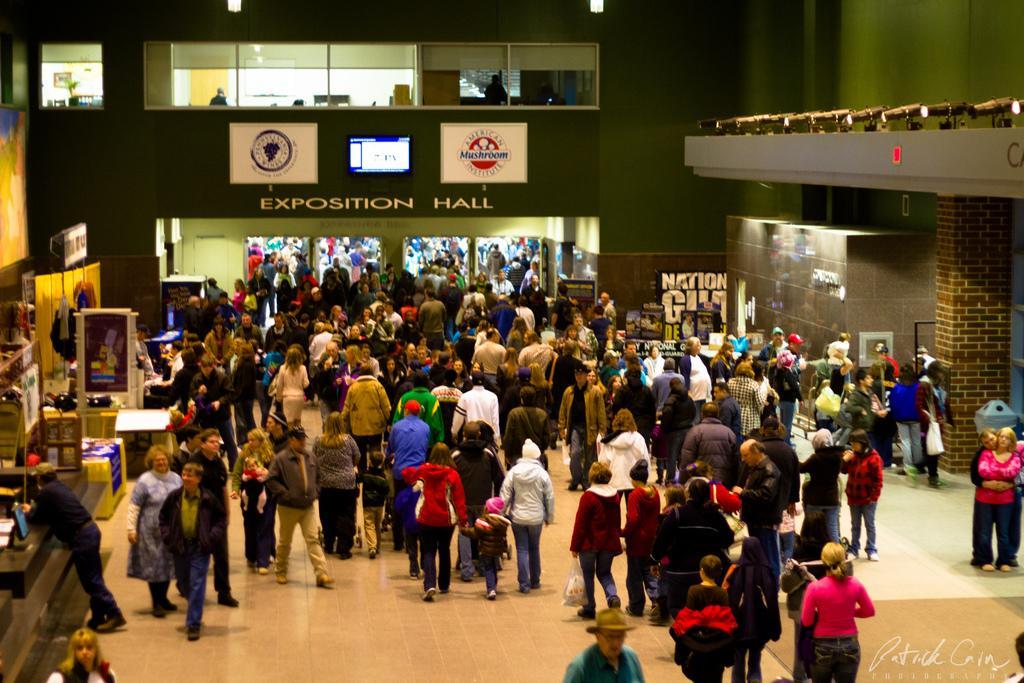Can you describe this image briefly? In this picture we can see some people are standing and some people are walking on the path. On the left side of the people there is a board, a monitor and some objects. At the top of the wall there are boards and a screen and on the left side of the people, it looks like a dustbin. On the image there is a watermark. 